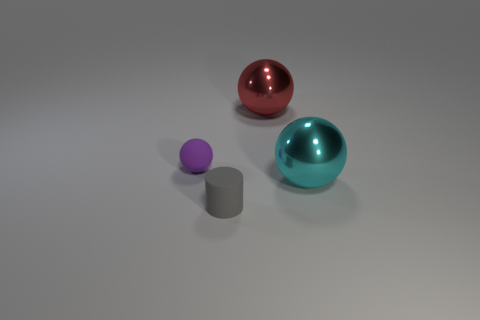Add 3 gray cylinders. How many objects exist? 7 Subtract all spheres. How many objects are left? 1 Subtract 0 red cylinders. How many objects are left? 4 Subtract all cylinders. Subtract all gray objects. How many objects are left? 2 Add 1 cylinders. How many cylinders are left? 2 Add 2 small blue matte objects. How many small blue matte objects exist? 2 